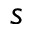<formula> <loc_0><loc_0><loc_500><loc_500>s</formula> 